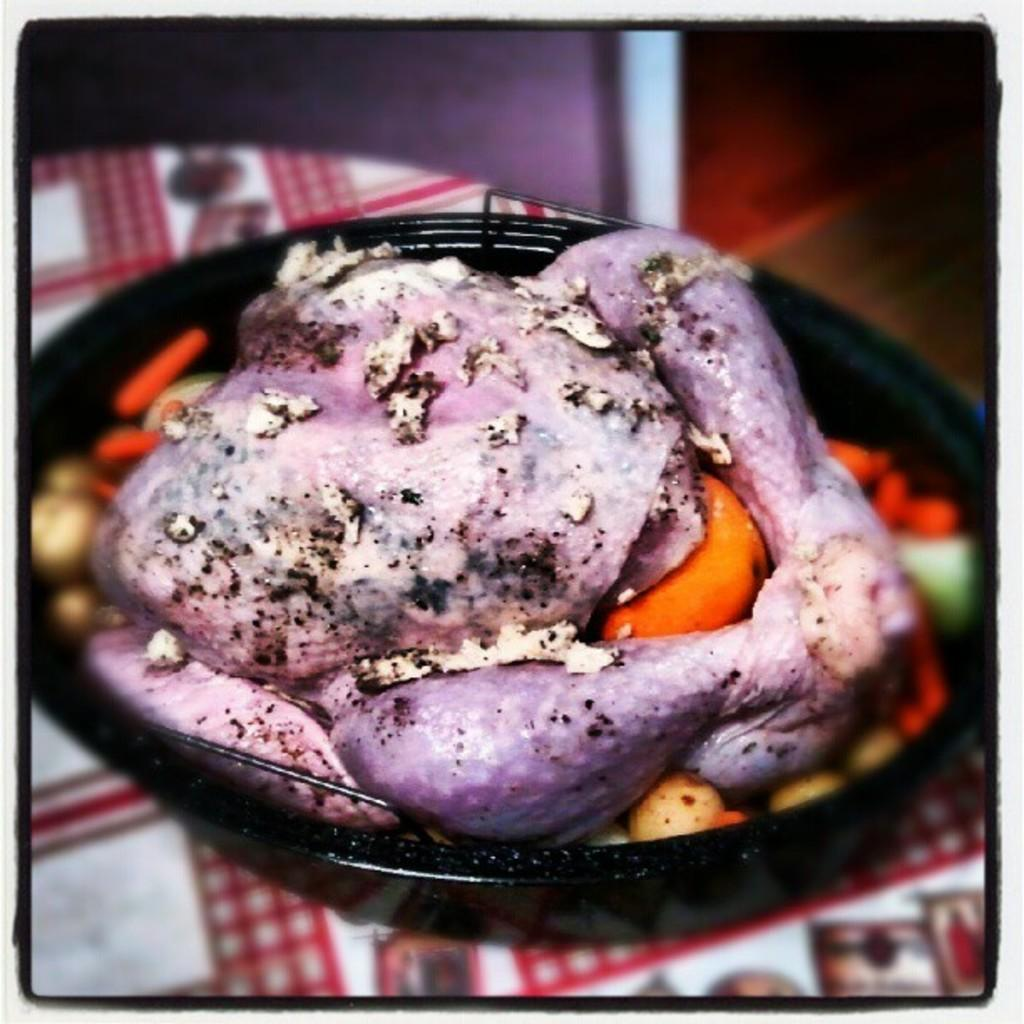What animal is present in the image? There is a chicken in the image. What is the chicken placed in? The chicken is in a black color pan. What type of tax is being discussed in relation to the chicken in the image? There is no mention of tax or any discussion related to tax in the image. 